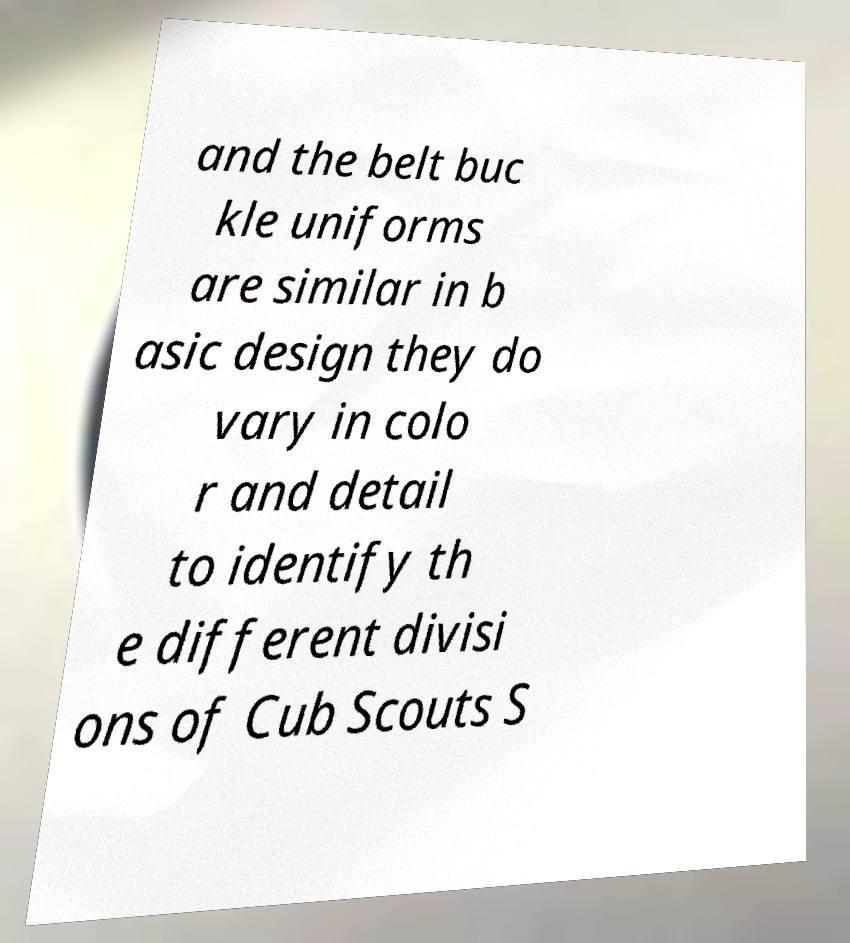Please identify and transcribe the text found in this image. and the belt buc kle uniforms are similar in b asic design they do vary in colo r and detail to identify th e different divisi ons of Cub Scouts S 